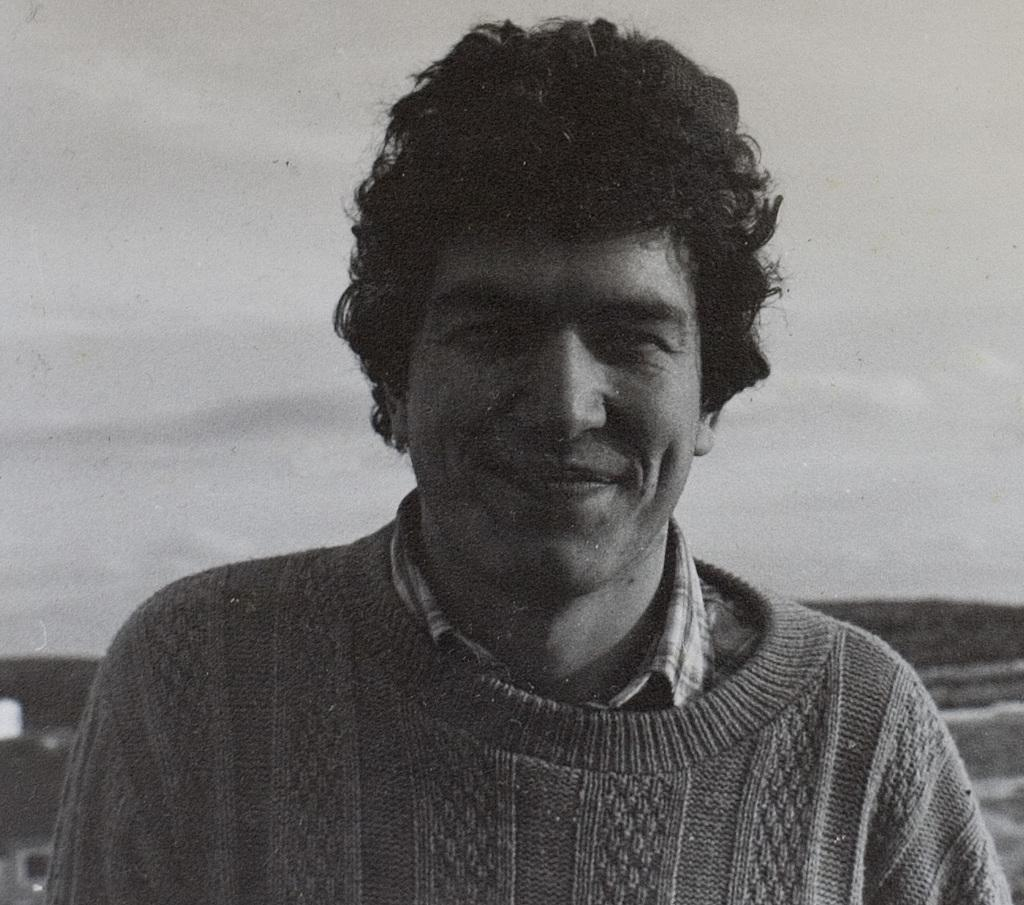What is present in the image? There is a person in the image. How is the person's expression in the image? The person is smiling. What type of vegetable is the person holding in the image? There is no vegetable present in the image; the person is simply smiling. 